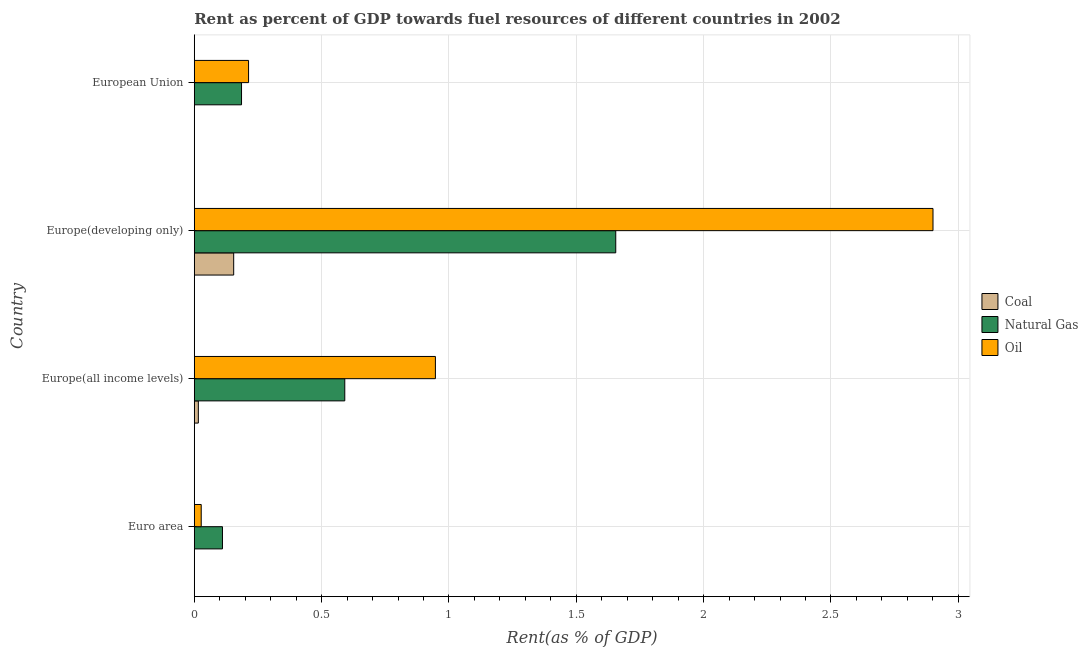How many different coloured bars are there?
Keep it short and to the point. 3. How many groups of bars are there?
Your answer should be very brief. 4. What is the rent towards natural gas in Europe(developing only)?
Your answer should be compact. 1.65. Across all countries, what is the maximum rent towards natural gas?
Ensure brevity in your answer.  1.65. Across all countries, what is the minimum rent towards oil?
Your answer should be compact. 0.03. In which country was the rent towards natural gas maximum?
Give a very brief answer. Europe(developing only). In which country was the rent towards oil minimum?
Provide a short and direct response. Euro area. What is the total rent towards natural gas in the graph?
Offer a terse response. 2.54. What is the difference between the rent towards natural gas in Euro area and that in Europe(developing only)?
Provide a succinct answer. -1.54. What is the difference between the rent towards coal in Europe(developing only) and the rent towards natural gas in Euro area?
Make the answer very short. 0.04. What is the average rent towards oil per country?
Offer a very short reply. 1.02. What is the difference between the rent towards coal and rent towards natural gas in Euro area?
Provide a succinct answer. -0.11. In how many countries, is the rent towards coal greater than 1.9 %?
Provide a succinct answer. 0. What is the ratio of the rent towards oil in Europe(developing only) to that in European Union?
Offer a terse response. 13.61. Is the rent towards coal in Europe(all income levels) less than that in European Union?
Your response must be concise. No. Is the difference between the rent towards natural gas in Euro area and Europe(developing only) greater than the difference between the rent towards coal in Euro area and Europe(developing only)?
Your answer should be compact. No. What is the difference between the highest and the second highest rent towards oil?
Provide a short and direct response. 1.95. What is the difference between the highest and the lowest rent towards oil?
Offer a terse response. 2.87. Is the sum of the rent towards coal in Euro area and Europe(all income levels) greater than the maximum rent towards oil across all countries?
Give a very brief answer. No. What does the 3rd bar from the top in European Union represents?
Offer a very short reply. Coal. What does the 3rd bar from the bottom in Europe(all income levels) represents?
Keep it short and to the point. Oil. How many bars are there?
Keep it short and to the point. 12. Are all the bars in the graph horizontal?
Keep it short and to the point. Yes. Are the values on the major ticks of X-axis written in scientific E-notation?
Provide a short and direct response. No. Does the graph contain any zero values?
Your answer should be very brief. No. What is the title of the graph?
Your answer should be compact. Rent as percent of GDP towards fuel resources of different countries in 2002. Does "Textiles and clothing" appear as one of the legend labels in the graph?
Offer a very short reply. No. What is the label or title of the X-axis?
Provide a short and direct response. Rent(as % of GDP). What is the Rent(as % of GDP) in Coal in Euro area?
Provide a succinct answer. 0. What is the Rent(as % of GDP) in Natural Gas in Euro area?
Provide a short and direct response. 0.11. What is the Rent(as % of GDP) in Oil in Euro area?
Offer a very short reply. 0.03. What is the Rent(as % of GDP) of Coal in Europe(all income levels)?
Give a very brief answer. 0.02. What is the Rent(as % of GDP) of Natural Gas in Europe(all income levels)?
Keep it short and to the point. 0.59. What is the Rent(as % of GDP) of Oil in Europe(all income levels)?
Make the answer very short. 0.95. What is the Rent(as % of GDP) of Coal in Europe(developing only)?
Keep it short and to the point. 0.15. What is the Rent(as % of GDP) of Natural Gas in Europe(developing only)?
Give a very brief answer. 1.65. What is the Rent(as % of GDP) of Oil in Europe(developing only)?
Make the answer very short. 2.9. What is the Rent(as % of GDP) of Coal in European Union?
Keep it short and to the point. 0. What is the Rent(as % of GDP) of Natural Gas in European Union?
Your response must be concise. 0.19. What is the Rent(as % of GDP) in Oil in European Union?
Provide a short and direct response. 0.21. Across all countries, what is the maximum Rent(as % of GDP) in Coal?
Ensure brevity in your answer.  0.15. Across all countries, what is the maximum Rent(as % of GDP) in Natural Gas?
Your answer should be compact. 1.65. Across all countries, what is the maximum Rent(as % of GDP) in Oil?
Your answer should be compact. 2.9. Across all countries, what is the minimum Rent(as % of GDP) of Coal?
Your response must be concise. 0. Across all countries, what is the minimum Rent(as % of GDP) of Natural Gas?
Provide a succinct answer. 0.11. Across all countries, what is the minimum Rent(as % of GDP) in Oil?
Your response must be concise. 0.03. What is the total Rent(as % of GDP) in Coal in the graph?
Ensure brevity in your answer.  0.17. What is the total Rent(as % of GDP) in Natural Gas in the graph?
Keep it short and to the point. 2.54. What is the total Rent(as % of GDP) of Oil in the graph?
Give a very brief answer. 4.09. What is the difference between the Rent(as % of GDP) in Coal in Euro area and that in Europe(all income levels)?
Keep it short and to the point. -0.02. What is the difference between the Rent(as % of GDP) of Natural Gas in Euro area and that in Europe(all income levels)?
Offer a very short reply. -0.48. What is the difference between the Rent(as % of GDP) in Oil in Euro area and that in Europe(all income levels)?
Your answer should be compact. -0.92. What is the difference between the Rent(as % of GDP) of Coal in Euro area and that in Europe(developing only)?
Keep it short and to the point. -0.15. What is the difference between the Rent(as % of GDP) in Natural Gas in Euro area and that in Europe(developing only)?
Keep it short and to the point. -1.54. What is the difference between the Rent(as % of GDP) in Oil in Euro area and that in Europe(developing only)?
Offer a very short reply. -2.87. What is the difference between the Rent(as % of GDP) in Natural Gas in Euro area and that in European Union?
Provide a succinct answer. -0.07. What is the difference between the Rent(as % of GDP) of Oil in Euro area and that in European Union?
Keep it short and to the point. -0.19. What is the difference between the Rent(as % of GDP) of Coal in Europe(all income levels) and that in Europe(developing only)?
Keep it short and to the point. -0.14. What is the difference between the Rent(as % of GDP) of Natural Gas in Europe(all income levels) and that in Europe(developing only)?
Your answer should be compact. -1.06. What is the difference between the Rent(as % of GDP) in Oil in Europe(all income levels) and that in Europe(developing only)?
Provide a succinct answer. -1.95. What is the difference between the Rent(as % of GDP) of Coal in Europe(all income levels) and that in European Union?
Provide a short and direct response. 0.02. What is the difference between the Rent(as % of GDP) of Natural Gas in Europe(all income levels) and that in European Union?
Your answer should be very brief. 0.41. What is the difference between the Rent(as % of GDP) in Oil in Europe(all income levels) and that in European Union?
Offer a terse response. 0.73. What is the difference between the Rent(as % of GDP) in Coal in Europe(developing only) and that in European Union?
Your answer should be compact. 0.15. What is the difference between the Rent(as % of GDP) in Natural Gas in Europe(developing only) and that in European Union?
Make the answer very short. 1.47. What is the difference between the Rent(as % of GDP) of Oil in Europe(developing only) and that in European Union?
Provide a succinct answer. 2.69. What is the difference between the Rent(as % of GDP) of Coal in Euro area and the Rent(as % of GDP) of Natural Gas in Europe(all income levels)?
Your response must be concise. -0.59. What is the difference between the Rent(as % of GDP) in Coal in Euro area and the Rent(as % of GDP) in Oil in Europe(all income levels)?
Make the answer very short. -0.95. What is the difference between the Rent(as % of GDP) in Natural Gas in Euro area and the Rent(as % of GDP) in Oil in Europe(all income levels)?
Offer a very short reply. -0.84. What is the difference between the Rent(as % of GDP) in Coal in Euro area and the Rent(as % of GDP) in Natural Gas in Europe(developing only)?
Your answer should be compact. -1.65. What is the difference between the Rent(as % of GDP) of Coal in Euro area and the Rent(as % of GDP) of Oil in Europe(developing only)?
Ensure brevity in your answer.  -2.9. What is the difference between the Rent(as % of GDP) in Natural Gas in Euro area and the Rent(as % of GDP) in Oil in Europe(developing only)?
Make the answer very short. -2.79. What is the difference between the Rent(as % of GDP) in Coal in Euro area and the Rent(as % of GDP) in Natural Gas in European Union?
Your answer should be compact. -0.19. What is the difference between the Rent(as % of GDP) of Coal in Euro area and the Rent(as % of GDP) of Oil in European Union?
Make the answer very short. -0.21. What is the difference between the Rent(as % of GDP) in Natural Gas in Euro area and the Rent(as % of GDP) in Oil in European Union?
Provide a succinct answer. -0.1. What is the difference between the Rent(as % of GDP) in Coal in Europe(all income levels) and the Rent(as % of GDP) in Natural Gas in Europe(developing only)?
Your answer should be very brief. -1.64. What is the difference between the Rent(as % of GDP) in Coal in Europe(all income levels) and the Rent(as % of GDP) in Oil in Europe(developing only)?
Offer a very short reply. -2.88. What is the difference between the Rent(as % of GDP) of Natural Gas in Europe(all income levels) and the Rent(as % of GDP) of Oil in Europe(developing only)?
Give a very brief answer. -2.31. What is the difference between the Rent(as % of GDP) in Coal in Europe(all income levels) and the Rent(as % of GDP) in Natural Gas in European Union?
Provide a succinct answer. -0.17. What is the difference between the Rent(as % of GDP) of Coal in Europe(all income levels) and the Rent(as % of GDP) of Oil in European Union?
Keep it short and to the point. -0.2. What is the difference between the Rent(as % of GDP) of Natural Gas in Europe(all income levels) and the Rent(as % of GDP) of Oil in European Union?
Keep it short and to the point. 0.38. What is the difference between the Rent(as % of GDP) of Coal in Europe(developing only) and the Rent(as % of GDP) of Natural Gas in European Union?
Offer a very short reply. -0.03. What is the difference between the Rent(as % of GDP) of Coal in Europe(developing only) and the Rent(as % of GDP) of Oil in European Union?
Your response must be concise. -0.06. What is the difference between the Rent(as % of GDP) in Natural Gas in Europe(developing only) and the Rent(as % of GDP) in Oil in European Union?
Provide a succinct answer. 1.44. What is the average Rent(as % of GDP) in Coal per country?
Give a very brief answer. 0.04. What is the average Rent(as % of GDP) in Natural Gas per country?
Provide a succinct answer. 0.64. What is the average Rent(as % of GDP) in Oil per country?
Your response must be concise. 1.02. What is the difference between the Rent(as % of GDP) of Coal and Rent(as % of GDP) of Natural Gas in Euro area?
Keep it short and to the point. -0.11. What is the difference between the Rent(as % of GDP) of Coal and Rent(as % of GDP) of Oil in Euro area?
Your answer should be very brief. -0.03. What is the difference between the Rent(as % of GDP) in Natural Gas and Rent(as % of GDP) in Oil in Euro area?
Provide a succinct answer. 0.08. What is the difference between the Rent(as % of GDP) of Coal and Rent(as % of GDP) of Natural Gas in Europe(all income levels)?
Provide a short and direct response. -0.57. What is the difference between the Rent(as % of GDP) of Coal and Rent(as % of GDP) of Oil in Europe(all income levels)?
Give a very brief answer. -0.93. What is the difference between the Rent(as % of GDP) of Natural Gas and Rent(as % of GDP) of Oil in Europe(all income levels)?
Keep it short and to the point. -0.36. What is the difference between the Rent(as % of GDP) of Coal and Rent(as % of GDP) of Natural Gas in Europe(developing only)?
Your response must be concise. -1.5. What is the difference between the Rent(as % of GDP) in Coal and Rent(as % of GDP) in Oil in Europe(developing only)?
Ensure brevity in your answer.  -2.75. What is the difference between the Rent(as % of GDP) in Natural Gas and Rent(as % of GDP) in Oil in Europe(developing only)?
Keep it short and to the point. -1.25. What is the difference between the Rent(as % of GDP) of Coal and Rent(as % of GDP) of Natural Gas in European Union?
Keep it short and to the point. -0.19. What is the difference between the Rent(as % of GDP) of Coal and Rent(as % of GDP) of Oil in European Union?
Your answer should be compact. -0.21. What is the difference between the Rent(as % of GDP) in Natural Gas and Rent(as % of GDP) in Oil in European Union?
Give a very brief answer. -0.03. What is the ratio of the Rent(as % of GDP) in Coal in Euro area to that in Europe(all income levels)?
Your response must be concise. 0.02. What is the ratio of the Rent(as % of GDP) in Natural Gas in Euro area to that in Europe(all income levels)?
Provide a short and direct response. 0.19. What is the ratio of the Rent(as % of GDP) of Oil in Euro area to that in Europe(all income levels)?
Your answer should be compact. 0.03. What is the ratio of the Rent(as % of GDP) of Coal in Euro area to that in Europe(developing only)?
Provide a succinct answer. 0. What is the ratio of the Rent(as % of GDP) in Natural Gas in Euro area to that in Europe(developing only)?
Provide a succinct answer. 0.07. What is the ratio of the Rent(as % of GDP) of Oil in Euro area to that in Europe(developing only)?
Your answer should be compact. 0.01. What is the ratio of the Rent(as % of GDP) of Coal in Euro area to that in European Union?
Provide a succinct answer. 1.36. What is the ratio of the Rent(as % of GDP) of Natural Gas in Euro area to that in European Union?
Offer a terse response. 0.6. What is the ratio of the Rent(as % of GDP) of Oil in Euro area to that in European Union?
Offer a very short reply. 0.13. What is the ratio of the Rent(as % of GDP) in Coal in Europe(all income levels) to that in Europe(developing only)?
Provide a short and direct response. 0.1. What is the ratio of the Rent(as % of GDP) of Natural Gas in Europe(all income levels) to that in Europe(developing only)?
Offer a very short reply. 0.36. What is the ratio of the Rent(as % of GDP) of Oil in Europe(all income levels) to that in Europe(developing only)?
Keep it short and to the point. 0.33. What is the ratio of the Rent(as % of GDP) of Coal in Europe(all income levels) to that in European Union?
Your response must be concise. 87.97. What is the ratio of the Rent(as % of GDP) in Natural Gas in Europe(all income levels) to that in European Union?
Ensure brevity in your answer.  3.18. What is the ratio of the Rent(as % of GDP) of Oil in Europe(all income levels) to that in European Union?
Your answer should be compact. 4.44. What is the ratio of the Rent(as % of GDP) of Coal in Europe(developing only) to that in European Union?
Your response must be concise. 851.57. What is the ratio of the Rent(as % of GDP) of Natural Gas in Europe(developing only) to that in European Union?
Keep it short and to the point. 8.92. What is the ratio of the Rent(as % of GDP) of Oil in Europe(developing only) to that in European Union?
Keep it short and to the point. 13.61. What is the difference between the highest and the second highest Rent(as % of GDP) in Coal?
Give a very brief answer. 0.14. What is the difference between the highest and the second highest Rent(as % of GDP) in Natural Gas?
Ensure brevity in your answer.  1.06. What is the difference between the highest and the second highest Rent(as % of GDP) of Oil?
Your answer should be very brief. 1.95. What is the difference between the highest and the lowest Rent(as % of GDP) in Coal?
Offer a terse response. 0.15. What is the difference between the highest and the lowest Rent(as % of GDP) of Natural Gas?
Your response must be concise. 1.54. What is the difference between the highest and the lowest Rent(as % of GDP) in Oil?
Ensure brevity in your answer.  2.87. 